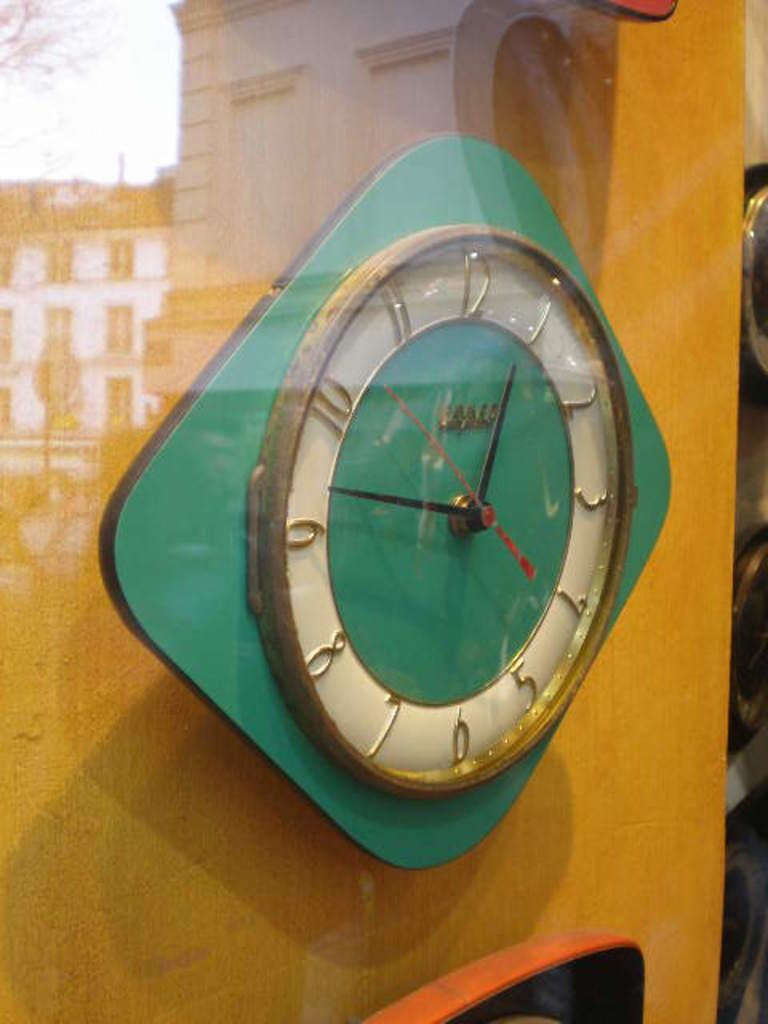Provide a one-sentence caption for the provided image. Green clcok which has the hands on the numbers 1 and 9. 